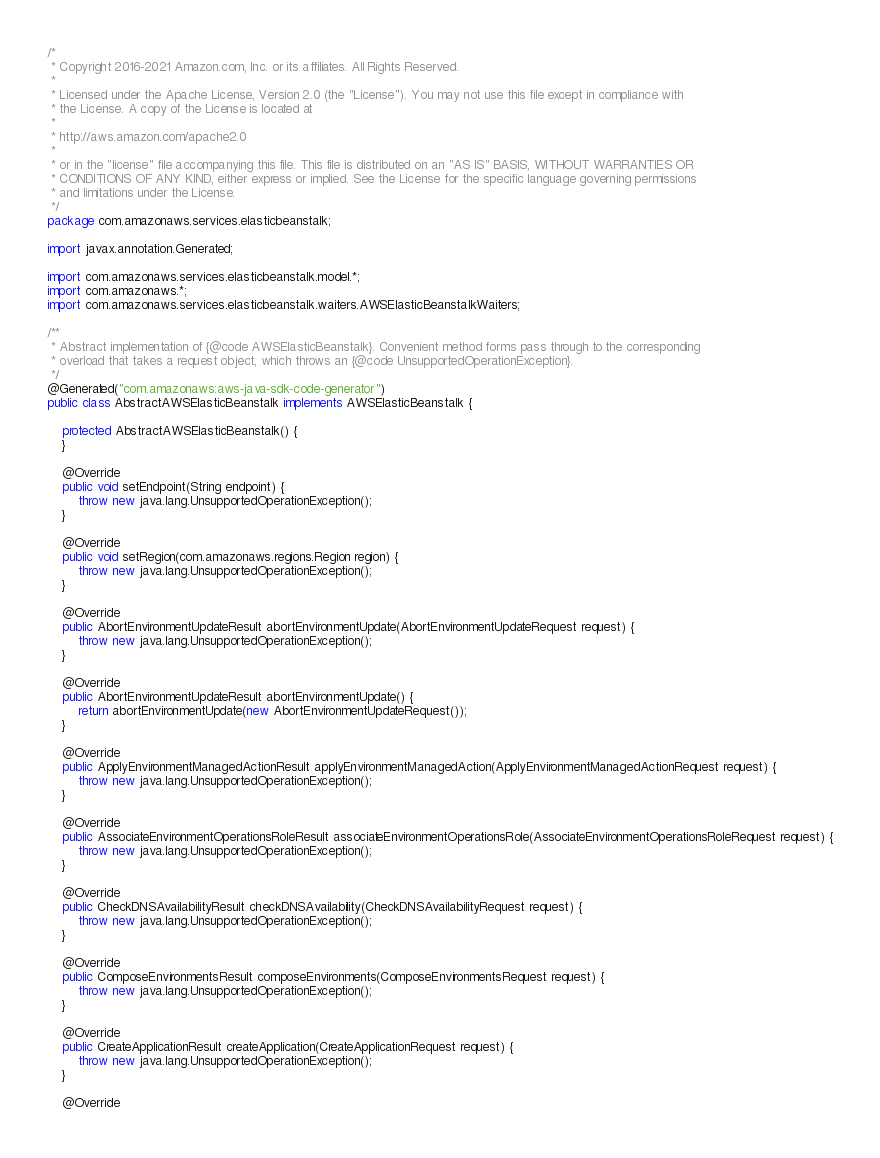Convert code to text. <code><loc_0><loc_0><loc_500><loc_500><_Java_>/*
 * Copyright 2016-2021 Amazon.com, Inc. or its affiliates. All Rights Reserved.
 * 
 * Licensed under the Apache License, Version 2.0 (the "License"). You may not use this file except in compliance with
 * the License. A copy of the License is located at
 * 
 * http://aws.amazon.com/apache2.0
 * 
 * or in the "license" file accompanying this file. This file is distributed on an "AS IS" BASIS, WITHOUT WARRANTIES OR
 * CONDITIONS OF ANY KIND, either express or implied. See the License for the specific language governing permissions
 * and limitations under the License.
 */
package com.amazonaws.services.elasticbeanstalk;

import javax.annotation.Generated;

import com.amazonaws.services.elasticbeanstalk.model.*;
import com.amazonaws.*;
import com.amazonaws.services.elasticbeanstalk.waiters.AWSElasticBeanstalkWaiters;

/**
 * Abstract implementation of {@code AWSElasticBeanstalk}. Convenient method forms pass through to the corresponding
 * overload that takes a request object, which throws an {@code UnsupportedOperationException}.
 */
@Generated("com.amazonaws:aws-java-sdk-code-generator")
public class AbstractAWSElasticBeanstalk implements AWSElasticBeanstalk {

    protected AbstractAWSElasticBeanstalk() {
    }

    @Override
    public void setEndpoint(String endpoint) {
        throw new java.lang.UnsupportedOperationException();
    }

    @Override
    public void setRegion(com.amazonaws.regions.Region region) {
        throw new java.lang.UnsupportedOperationException();
    }

    @Override
    public AbortEnvironmentUpdateResult abortEnvironmentUpdate(AbortEnvironmentUpdateRequest request) {
        throw new java.lang.UnsupportedOperationException();
    }

    @Override
    public AbortEnvironmentUpdateResult abortEnvironmentUpdate() {
        return abortEnvironmentUpdate(new AbortEnvironmentUpdateRequest());
    }

    @Override
    public ApplyEnvironmentManagedActionResult applyEnvironmentManagedAction(ApplyEnvironmentManagedActionRequest request) {
        throw new java.lang.UnsupportedOperationException();
    }

    @Override
    public AssociateEnvironmentOperationsRoleResult associateEnvironmentOperationsRole(AssociateEnvironmentOperationsRoleRequest request) {
        throw new java.lang.UnsupportedOperationException();
    }

    @Override
    public CheckDNSAvailabilityResult checkDNSAvailability(CheckDNSAvailabilityRequest request) {
        throw new java.lang.UnsupportedOperationException();
    }

    @Override
    public ComposeEnvironmentsResult composeEnvironments(ComposeEnvironmentsRequest request) {
        throw new java.lang.UnsupportedOperationException();
    }

    @Override
    public CreateApplicationResult createApplication(CreateApplicationRequest request) {
        throw new java.lang.UnsupportedOperationException();
    }

    @Override</code> 